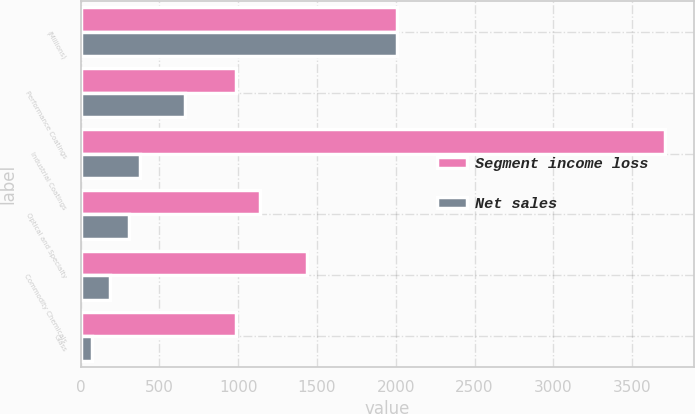Convert chart to OTSL. <chart><loc_0><loc_0><loc_500><loc_500><stacked_bar_chart><ecel><fcel>(Millions)<fcel>Performance Coatings<fcel>Industrial Coatings<fcel>Optical and Specialty<fcel>Commodity Chemicals<fcel>Glass<nl><fcel>Segment income loss<fcel>2010<fcel>985<fcel>3708<fcel>1141<fcel>1434<fcel>985<nl><fcel>Net sales<fcel>2010<fcel>661<fcel>378<fcel>307<fcel>189<fcel>74<nl></chart> 